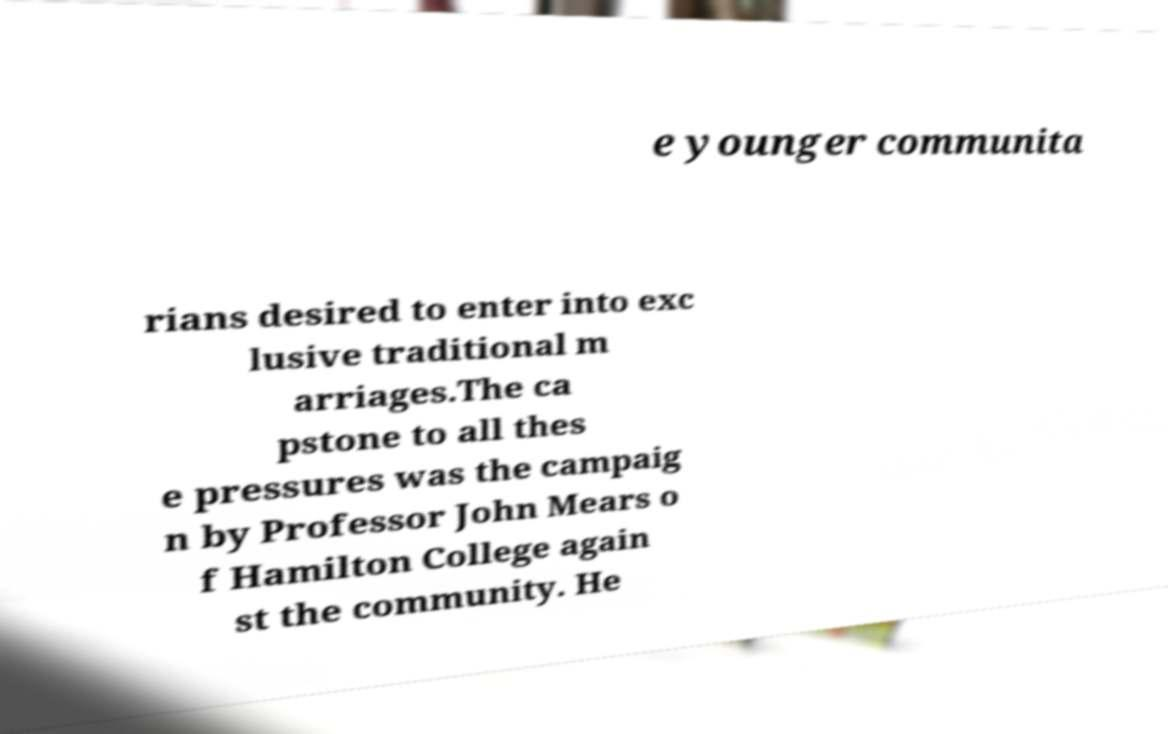Please read and relay the text visible in this image. What does it say? e younger communita rians desired to enter into exc lusive traditional m arriages.The ca pstone to all thes e pressures was the campaig n by Professor John Mears o f Hamilton College again st the community. He 